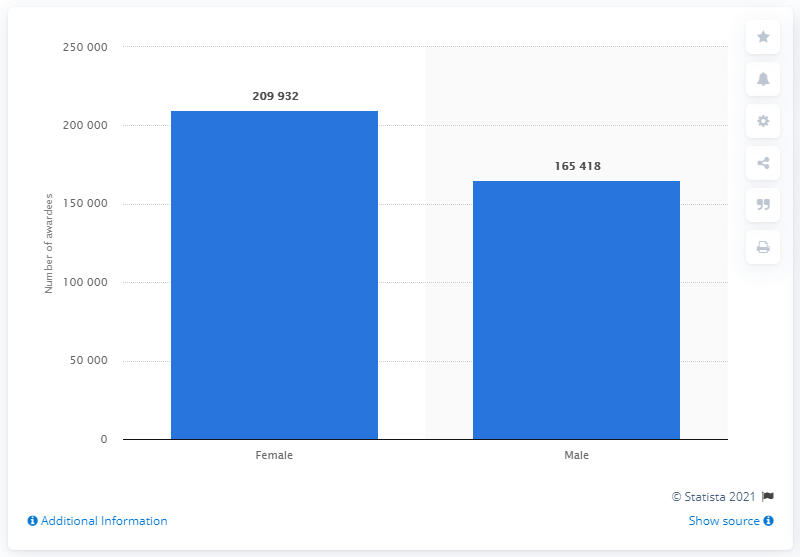Can you detail the trend in gender disparity in educational attainment shown in the graph? The graph clearly presents a significant gender disparity in educational attainment in Karnataka for 2019, with females achieving higher graduation rates than males. This suggests progressive trends in educational opportunities and achievements among women in the region. 